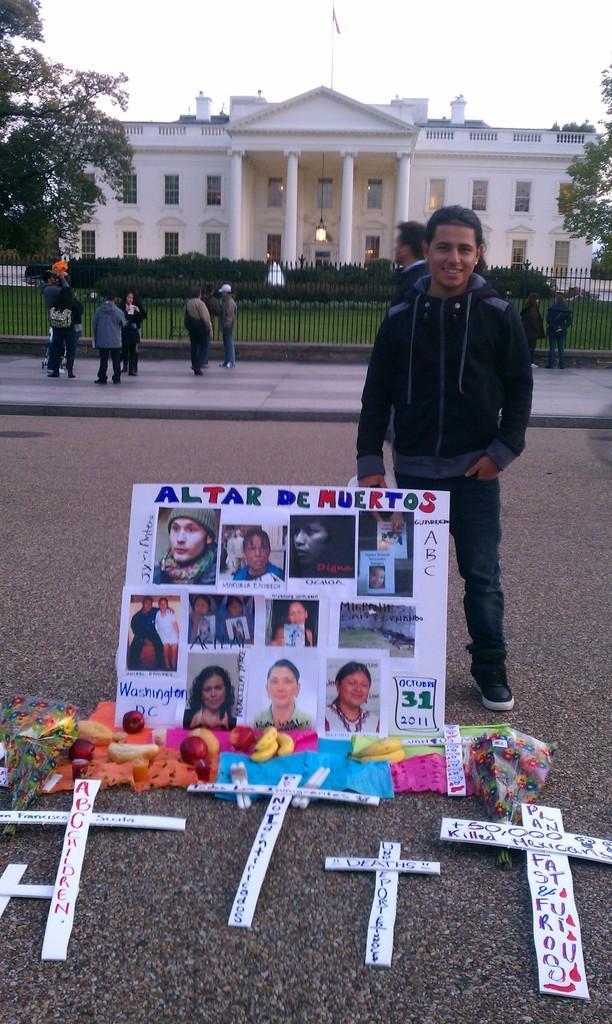Describe this image in one or two sentences. In this picture there is a man who is wearing jacket, jeans and sneakers. He is standing near to the board. On the board we can see persons photos, beside that we can see the cross mark, flowers, clothes and bouquet. In the background there is a building. On the left we can see the group of persons standing on the road. Behind them there is a fencing. In front of the building we can see the plants and grass. On the right there is a tree. At the top of the building where there is a flag. At the top we can see sky and clouds. 